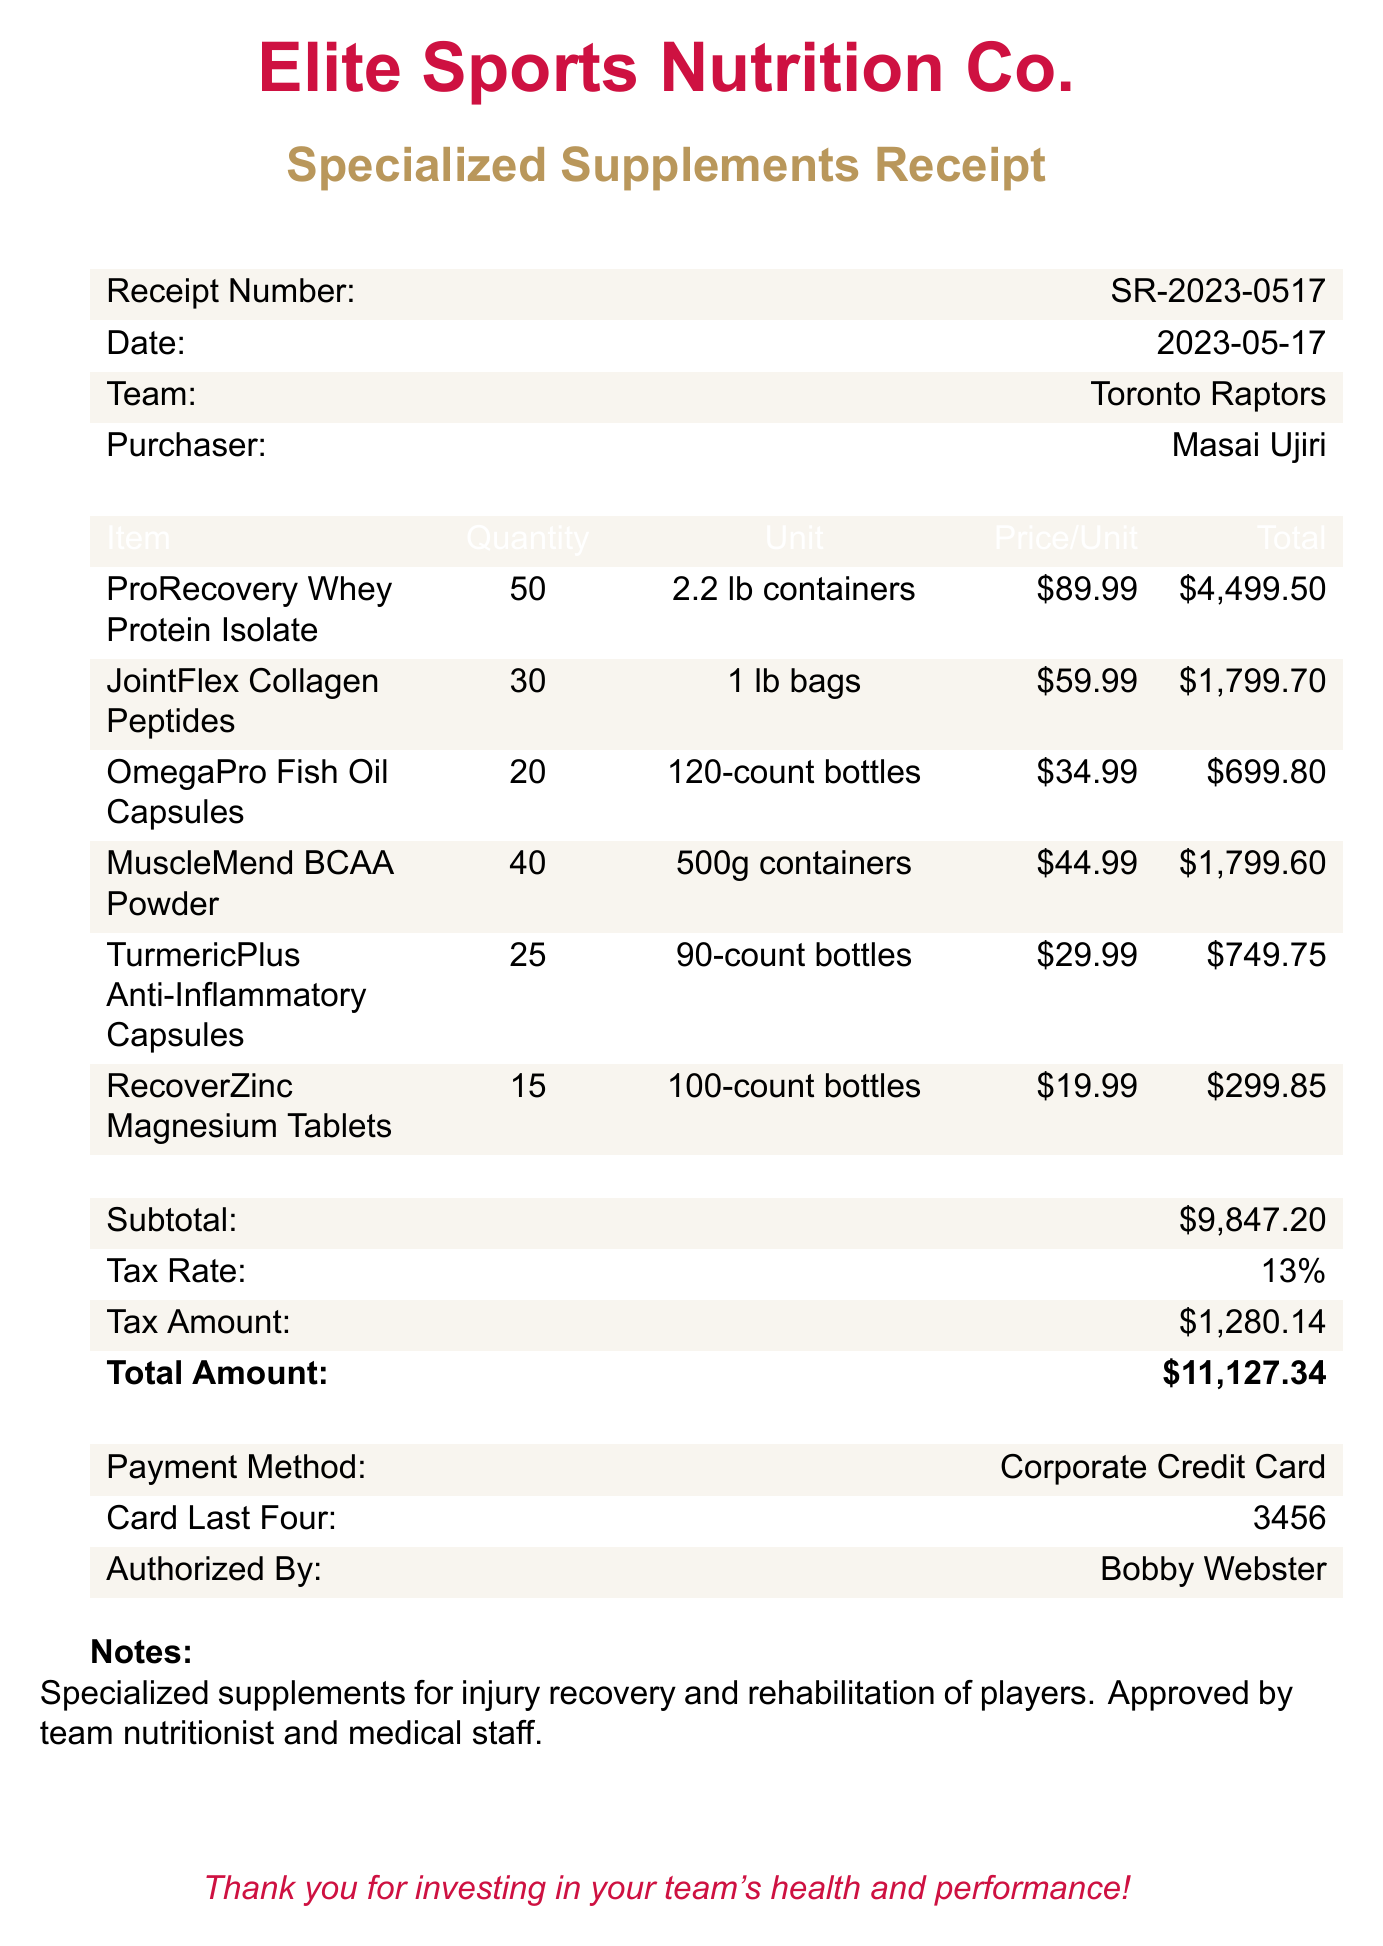What is the receipt number? The receipt number is listed at the top of the document, denoted clearly for reference.
Answer: SR-2023-0517 Who is the purchaser? The purchaser's name is mentioned in the document, identifying who made the transaction.
Answer: Masai Ujiri What is the date of the transaction? The date is found within the header information of the receipt, indicating when the purchase was made.
Answer: 2023-05-17 What is the total amount charged? The total amount is calculated by summing the subtotal and tax amount, presented prominently on the receipt.
Answer: $11,127.34 How many units of ProRecovery Whey Protein Isolate were purchased? The quantity of units for each item is specified in the item list, making it easy to see how much was bought.
Answer: 50 What type of payment method was used? The payment method is clearly stated at the end of the document, showing how the transaction was completed.
Answer: Corporate Credit Card What was the tax amount applied? The tax amount is provided in the subtotals, showcasing the additional charges beyond the subtotal.
Answer: $1,280.14 Who authorized the purchase? The name of the person who authorized the transaction is detailed under the payment information section.
Answer: Bobby Webster What is the primary purpose of these supplements? The notes at the bottom specify the intended use of the products purchased.
Answer: Injury recovery and rehabilitation 